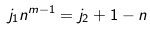<formula> <loc_0><loc_0><loc_500><loc_500>j _ { 1 } n ^ { m - 1 } = j _ { 2 } + 1 - n</formula> 